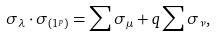<formula> <loc_0><loc_0><loc_500><loc_500>\sigma _ { \lambda } \cdot \sigma _ { ( 1 ^ { p } ) } = \sum \sigma _ { \mu } + q \sum \sigma _ { \nu } ,</formula> 